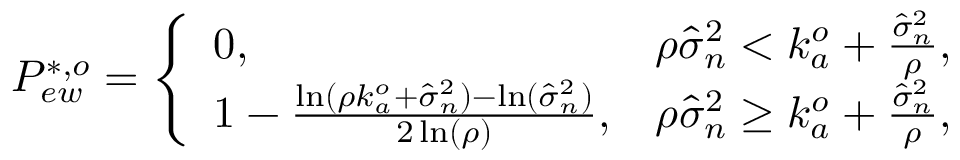Convert formula to latex. <formula><loc_0><loc_0><loc_500><loc_500>\begin{array} { r } { P _ { e w } ^ { * , o } = \left \{ \begin{array} { l l } { 0 , } & { \rho \hat { \sigma } _ { n } ^ { 2 } < k _ { a } ^ { o } + \frac { \hat { \sigma } _ { n } ^ { 2 } } { \rho } , } \\ { 1 - \frac { \ln ( \rho k _ { a } ^ { o } + \hat { \sigma } _ { n } ^ { 2 } ) - \ln ( \hat { \sigma } _ { n } ^ { 2 } ) } { 2 \ln ( \rho ) } , } & { \rho \hat { \sigma } _ { n } ^ { 2 } \geq k _ { a } ^ { o } + \frac { \hat { \sigma } _ { n } ^ { 2 } } { \rho } , } \end{array} } \end{array}</formula> 